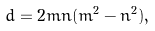Convert formula to latex. <formula><loc_0><loc_0><loc_500><loc_500>d = 2 m n ( m ^ { 2 } - n ^ { 2 } ) ,</formula> 